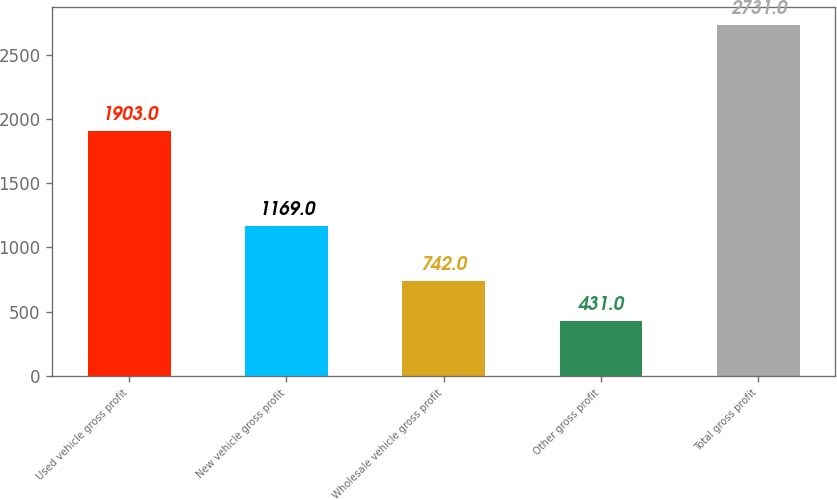Convert chart. <chart><loc_0><loc_0><loc_500><loc_500><bar_chart><fcel>Used vehicle gross profit<fcel>New vehicle gross profit<fcel>Wholesale vehicle gross profit<fcel>Other gross profit<fcel>Total gross profit<nl><fcel>1903<fcel>1169<fcel>742<fcel>431<fcel>2731<nl></chart> 